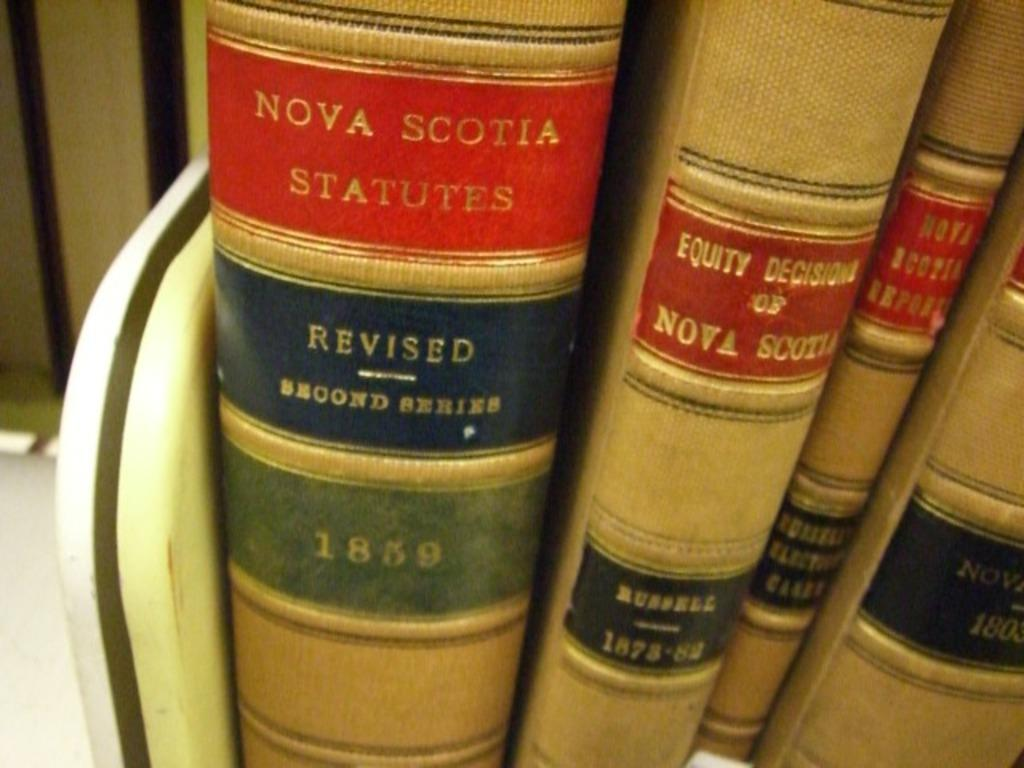<image>
Write a terse but informative summary of the picture. Nova Scotia legal information is in books with spines visible. 